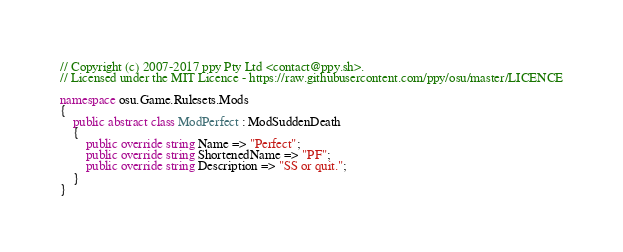Convert code to text. <code><loc_0><loc_0><loc_500><loc_500><_C#_>// Copyright (c) 2007-2017 ppy Pty Ltd <contact@ppy.sh>.
// Licensed under the MIT Licence - https://raw.githubusercontent.com/ppy/osu/master/LICENCE

namespace osu.Game.Rulesets.Mods
{
    public abstract class ModPerfect : ModSuddenDeath
    {
        public override string Name => "Perfect";
        public override string ShortenedName => "PF";
        public override string Description => "SS or quit.";
    }
}</code> 